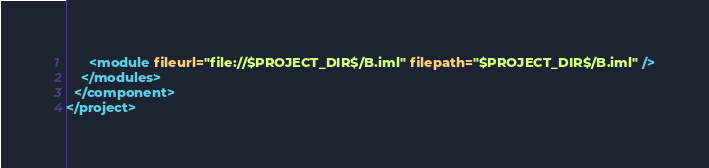<code> <loc_0><loc_0><loc_500><loc_500><_XML_>      <module fileurl="file://$PROJECT_DIR$/B.iml" filepath="$PROJECT_DIR$/B.iml" />
    </modules>
  </component>
</project></code> 